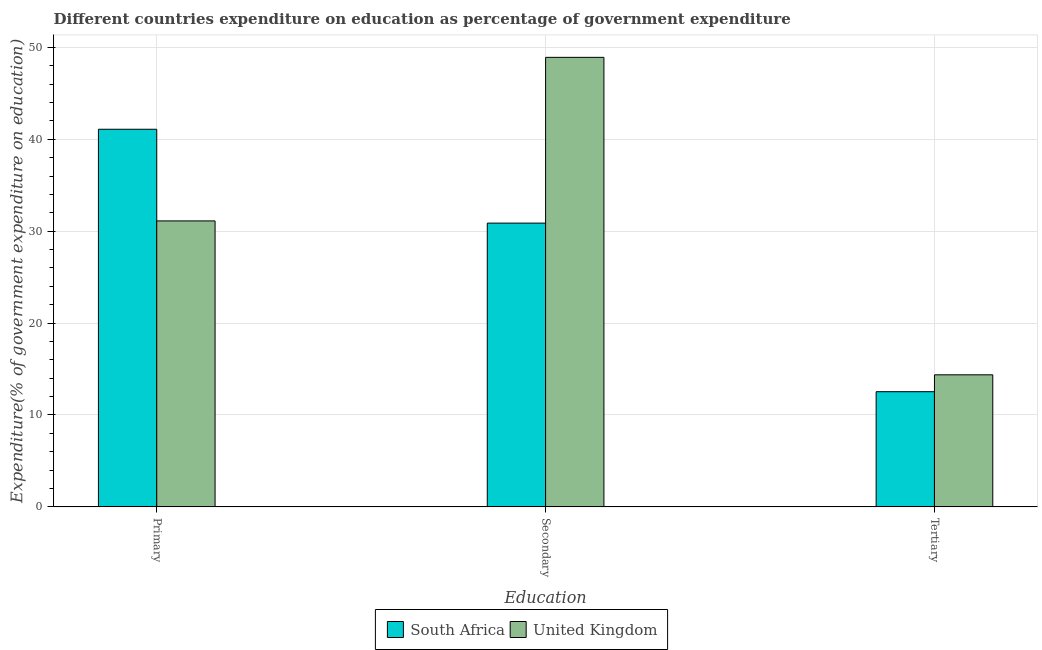How many different coloured bars are there?
Your response must be concise. 2. How many groups of bars are there?
Keep it short and to the point. 3. Are the number of bars per tick equal to the number of legend labels?
Offer a terse response. Yes. How many bars are there on the 3rd tick from the left?
Keep it short and to the point. 2. What is the label of the 2nd group of bars from the left?
Your response must be concise. Secondary. What is the expenditure on primary education in South Africa?
Keep it short and to the point. 41.09. Across all countries, what is the maximum expenditure on primary education?
Provide a succinct answer. 41.09. Across all countries, what is the minimum expenditure on secondary education?
Keep it short and to the point. 30.88. In which country was the expenditure on primary education maximum?
Ensure brevity in your answer.  South Africa. In which country was the expenditure on primary education minimum?
Your answer should be compact. United Kingdom. What is the total expenditure on tertiary education in the graph?
Ensure brevity in your answer.  26.9. What is the difference between the expenditure on secondary education in United Kingdom and that in South Africa?
Provide a succinct answer. 18.04. What is the difference between the expenditure on primary education in United Kingdom and the expenditure on secondary education in South Africa?
Make the answer very short. 0.24. What is the average expenditure on secondary education per country?
Provide a succinct answer. 39.9. What is the difference between the expenditure on tertiary education and expenditure on primary education in South Africa?
Provide a short and direct response. -28.56. What is the ratio of the expenditure on tertiary education in United Kingdom to that in South Africa?
Your answer should be compact. 1.15. Is the difference between the expenditure on secondary education in South Africa and United Kingdom greater than the difference between the expenditure on tertiary education in South Africa and United Kingdom?
Your answer should be very brief. No. What is the difference between the highest and the second highest expenditure on primary education?
Provide a succinct answer. 9.97. What is the difference between the highest and the lowest expenditure on primary education?
Give a very brief answer. 9.97. In how many countries, is the expenditure on primary education greater than the average expenditure on primary education taken over all countries?
Make the answer very short. 1. Is the sum of the expenditure on tertiary education in South Africa and United Kingdom greater than the maximum expenditure on primary education across all countries?
Offer a terse response. No. What does the 1st bar from the left in Secondary represents?
Your answer should be compact. South Africa. What does the 2nd bar from the right in Primary represents?
Provide a succinct answer. South Africa. Are all the bars in the graph horizontal?
Give a very brief answer. No. Are the values on the major ticks of Y-axis written in scientific E-notation?
Make the answer very short. No. Where does the legend appear in the graph?
Provide a succinct answer. Bottom center. What is the title of the graph?
Offer a terse response. Different countries expenditure on education as percentage of government expenditure. What is the label or title of the X-axis?
Give a very brief answer. Education. What is the label or title of the Y-axis?
Provide a succinct answer. Expenditure(% of government expenditure on education). What is the Expenditure(% of government expenditure on education) of South Africa in Primary?
Your answer should be compact. 41.09. What is the Expenditure(% of government expenditure on education) in United Kingdom in Primary?
Provide a short and direct response. 31.12. What is the Expenditure(% of government expenditure on education) of South Africa in Secondary?
Offer a terse response. 30.88. What is the Expenditure(% of government expenditure on education) in United Kingdom in Secondary?
Make the answer very short. 48.92. What is the Expenditure(% of government expenditure on education) of South Africa in Tertiary?
Offer a very short reply. 12.53. What is the Expenditure(% of government expenditure on education) of United Kingdom in Tertiary?
Your answer should be compact. 14.37. Across all Education, what is the maximum Expenditure(% of government expenditure on education) in South Africa?
Offer a very short reply. 41.09. Across all Education, what is the maximum Expenditure(% of government expenditure on education) in United Kingdom?
Your response must be concise. 48.92. Across all Education, what is the minimum Expenditure(% of government expenditure on education) of South Africa?
Ensure brevity in your answer.  12.53. Across all Education, what is the minimum Expenditure(% of government expenditure on education) in United Kingdom?
Provide a short and direct response. 14.37. What is the total Expenditure(% of government expenditure on education) of South Africa in the graph?
Your response must be concise. 84.51. What is the total Expenditure(% of government expenditure on education) in United Kingdom in the graph?
Provide a short and direct response. 94.41. What is the difference between the Expenditure(% of government expenditure on education) of South Africa in Primary and that in Secondary?
Your answer should be compact. 10.22. What is the difference between the Expenditure(% of government expenditure on education) of United Kingdom in Primary and that in Secondary?
Your answer should be very brief. -17.8. What is the difference between the Expenditure(% of government expenditure on education) in South Africa in Primary and that in Tertiary?
Make the answer very short. 28.56. What is the difference between the Expenditure(% of government expenditure on education) of United Kingdom in Primary and that in Tertiary?
Give a very brief answer. 16.75. What is the difference between the Expenditure(% of government expenditure on education) in South Africa in Secondary and that in Tertiary?
Give a very brief answer. 18.35. What is the difference between the Expenditure(% of government expenditure on education) in United Kingdom in Secondary and that in Tertiary?
Make the answer very short. 34.55. What is the difference between the Expenditure(% of government expenditure on education) of South Africa in Primary and the Expenditure(% of government expenditure on education) of United Kingdom in Secondary?
Provide a succinct answer. -7.82. What is the difference between the Expenditure(% of government expenditure on education) in South Africa in Primary and the Expenditure(% of government expenditure on education) in United Kingdom in Tertiary?
Make the answer very short. 26.72. What is the difference between the Expenditure(% of government expenditure on education) in South Africa in Secondary and the Expenditure(% of government expenditure on education) in United Kingdom in Tertiary?
Offer a terse response. 16.51. What is the average Expenditure(% of government expenditure on education) of South Africa per Education?
Your answer should be compact. 28.17. What is the average Expenditure(% of government expenditure on education) in United Kingdom per Education?
Ensure brevity in your answer.  31.47. What is the difference between the Expenditure(% of government expenditure on education) in South Africa and Expenditure(% of government expenditure on education) in United Kingdom in Primary?
Give a very brief answer. 9.97. What is the difference between the Expenditure(% of government expenditure on education) of South Africa and Expenditure(% of government expenditure on education) of United Kingdom in Secondary?
Your response must be concise. -18.04. What is the difference between the Expenditure(% of government expenditure on education) of South Africa and Expenditure(% of government expenditure on education) of United Kingdom in Tertiary?
Provide a succinct answer. -1.84. What is the ratio of the Expenditure(% of government expenditure on education) in South Africa in Primary to that in Secondary?
Offer a terse response. 1.33. What is the ratio of the Expenditure(% of government expenditure on education) in United Kingdom in Primary to that in Secondary?
Ensure brevity in your answer.  0.64. What is the ratio of the Expenditure(% of government expenditure on education) in South Africa in Primary to that in Tertiary?
Make the answer very short. 3.28. What is the ratio of the Expenditure(% of government expenditure on education) of United Kingdom in Primary to that in Tertiary?
Your answer should be compact. 2.17. What is the ratio of the Expenditure(% of government expenditure on education) in South Africa in Secondary to that in Tertiary?
Your answer should be very brief. 2.46. What is the ratio of the Expenditure(% of government expenditure on education) in United Kingdom in Secondary to that in Tertiary?
Your response must be concise. 3.4. What is the difference between the highest and the second highest Expenditure(% of government expenditure on education) in South Africa?
Keep it short and to the point. 10.22. What is the difference between the highest and the second highest Expenditure(% of government expenditure on education) of United Kingdom?
Provide a succinct answer. 17.8. What is the difference between the highest and the lowest Expenditure(% of government expenditure on education) of South Africa?
Provide a succinct answer. 28.56. What is the difference between the highest and the lowest Expenditure(% of government expenditure on education) in United Kingdom?
Give a very brief answer. 34.55. 